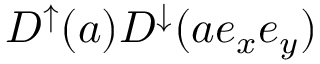Convert formula to latex. <formula><loc_0><loc_0><loc_500><loc_500>D ^ { \uparrow } ( a ) D ^ { \downarrow } ( a e _ { x } e _ { y } )</formula> 